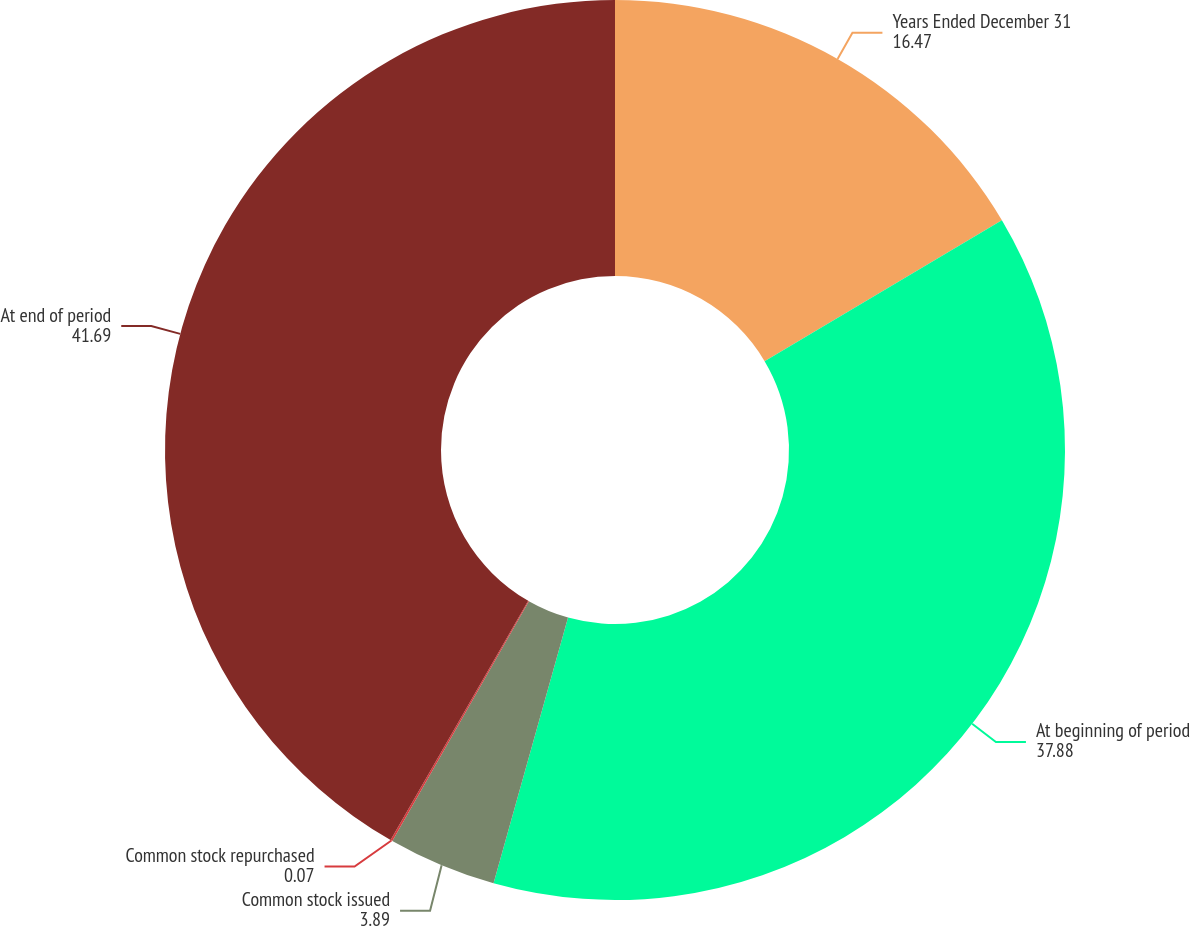Convert chart to OTSL. <chart><loc_0><loc_0><loc_500><loc_500><pie_chart><fcel>Years Ended December 31<fcel>At beginning of period<fcel>Common stock issued<fcel>Common stock repurchased<fcel>At end of period<nl><fcel>16.47%<fcel>37.88%<fcel>3.89%<fcel>0.07%<fcel>41.69%<nl></chart> 